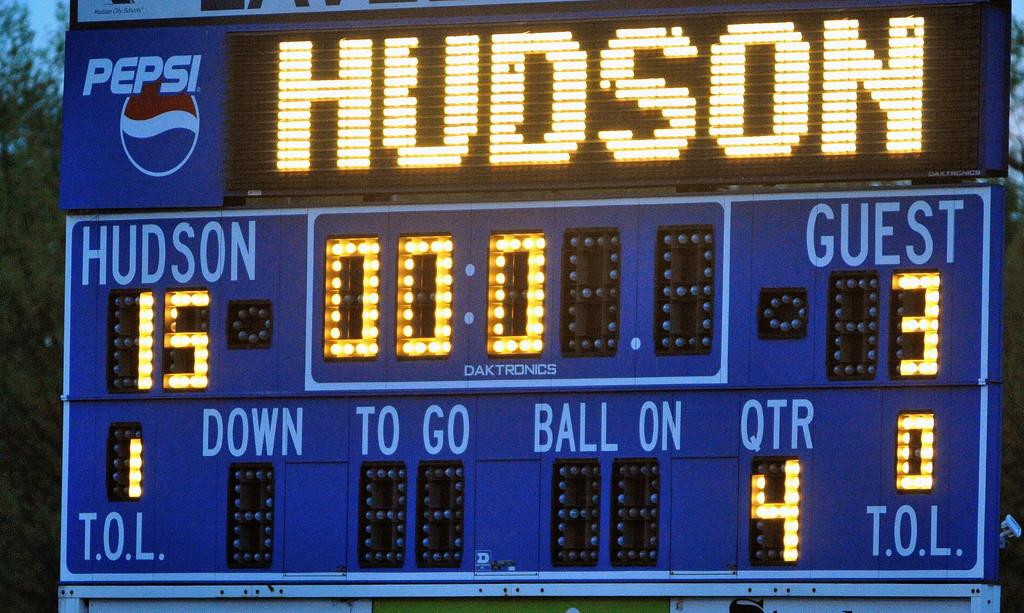<image>
Offer a succinct explanation of the picture presented. Hudson leads the road team by 12 points. 